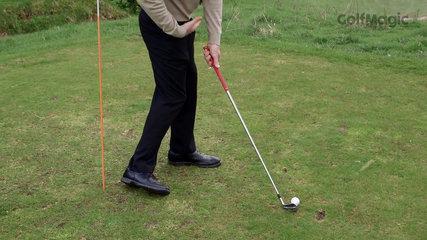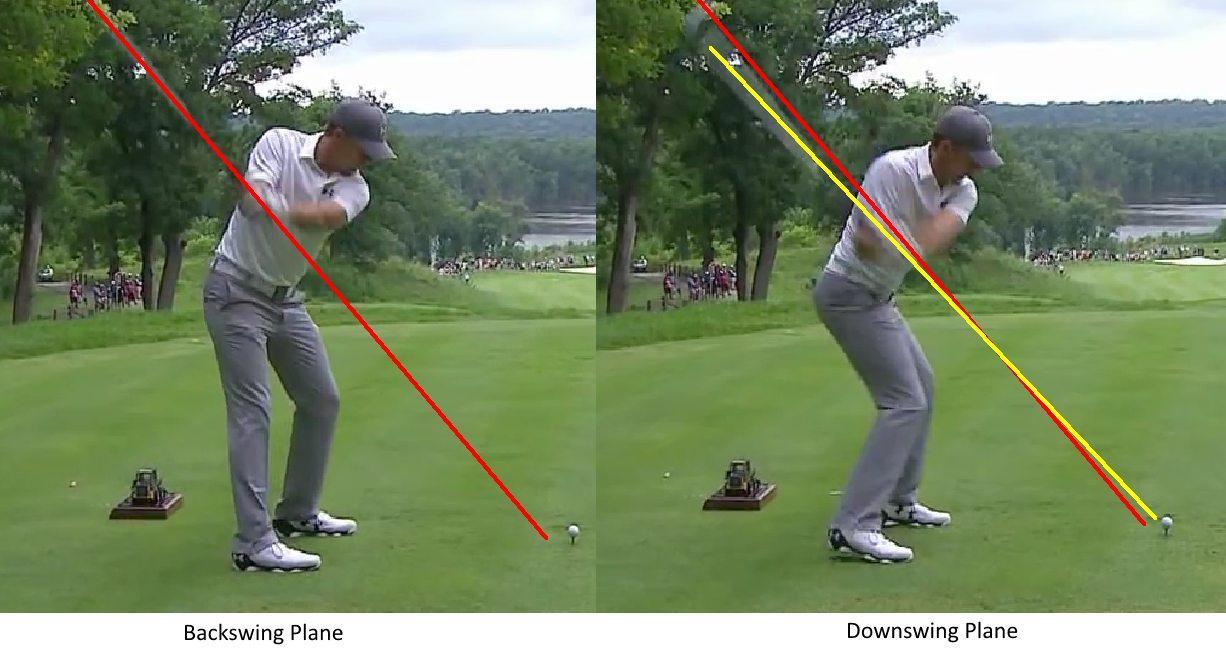The first image is the image on the left, the second image is the image on the right. Analyze the images presented: Is the assertion "The left image contains exactly three golf balls." valid? Answer yes or no. No. The first image is the image on the left, the second image is the image on the right. Given the left and right images, does the statement "One image shows a golf club and three balls, but no part of a golfer." hold true? Answer yes or no. No. 